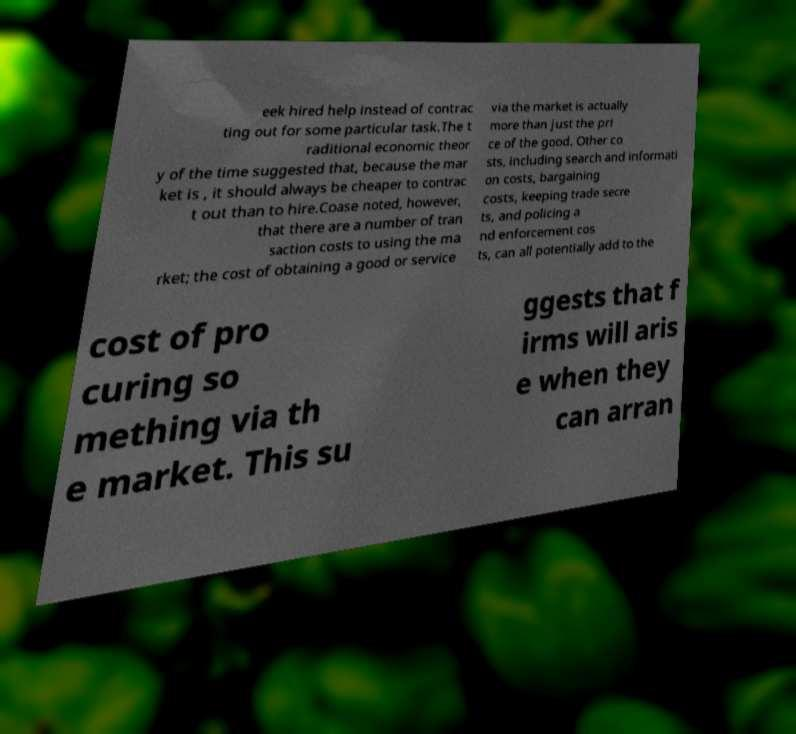Could you assist in decoding the text presented in this image and type it out clearly? eek hired help instead of contrac ting out for some particular task.The t raditional economic theor y of the time suggested that, because the mar ket is , it should always be cheaper to contrac t out than to hire.Coase noted, however, that there are a number of tran saction costs to using the ma rket; the cost of obtaining a good or service via the market is actually more than just the pri ce of the good. Other co sts, including search and informati on costs, bargaining costs, keeping trade secre ts, and policing a nd enforcement cos ts, can all potentially add to the cost of pro curing so mething via th e market. This su ggests that f irms will aris e when they can arran 